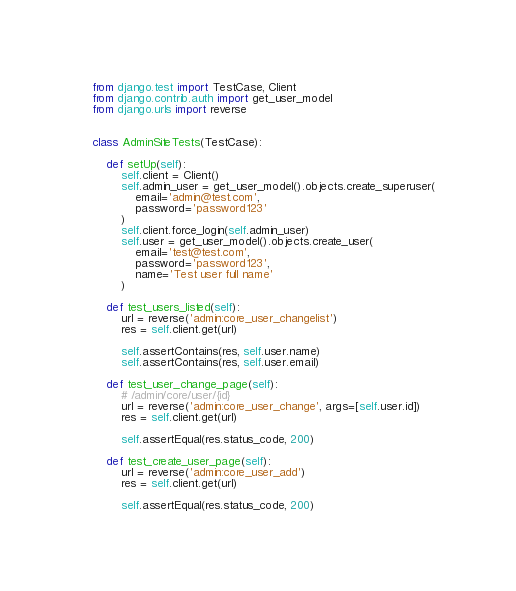<code> <loc_0><loc_0><loc_500><loc_500><_Python_>from django.test import TestCase, Client
from django.contrib.auth import get_user_model
from django.urls import reverse


class AdminSiteTests(TestCase):

    def setUp(self):
        self.client = Client()
        self.admin_user = get_user_model().objects.create_superuser(
            email='admin@test.com',
            password='password123'
        )
        self.client.force_login(self.admin_user)
        self.user = get_user_model().objects.create_user(
            email='test@test.com',
            password='password123',
            name='Test user full name'
        )

    def test_users_listed(self):
        url = reverse('admin:core_user_changelist')
        res = self.client.get(url)

        self.assertContains(res, self.user.name)
        self.assertContains(res, self.user.email)

    def test_user_change_page(self):
        # /admin/core/user/{id}
        url = reverse('admin:core_user_change', args=[self.user.id])
        res = self.client.get(url)

        self.assertEqual(res.status_code, 200)

    def test_create_user_page(self):
        url = reverse('admin:core_user_add')
        res = self.client.get(url)

        self.assertEqual(res.status_code, 200)
</code> 